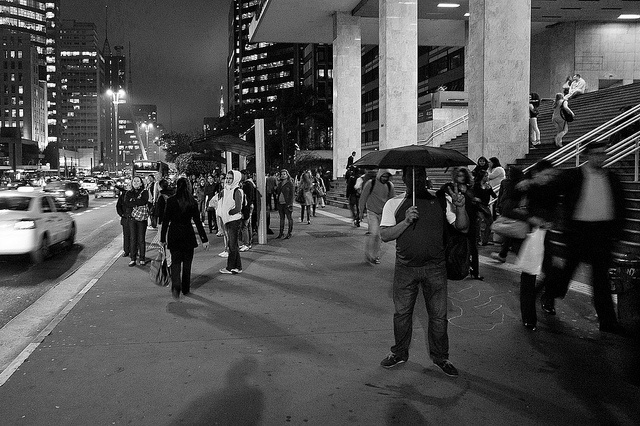Describe the objects in this image and their specific colors. I can see people in gray, black, darkgray, and lightgray tones, people in gray, black, darkgray, and lightgray tones, people in gray and black tones, people in gray, black, darkgray, and lightgray tones, and car in gray, black, white, and darkgray tones in this image. 